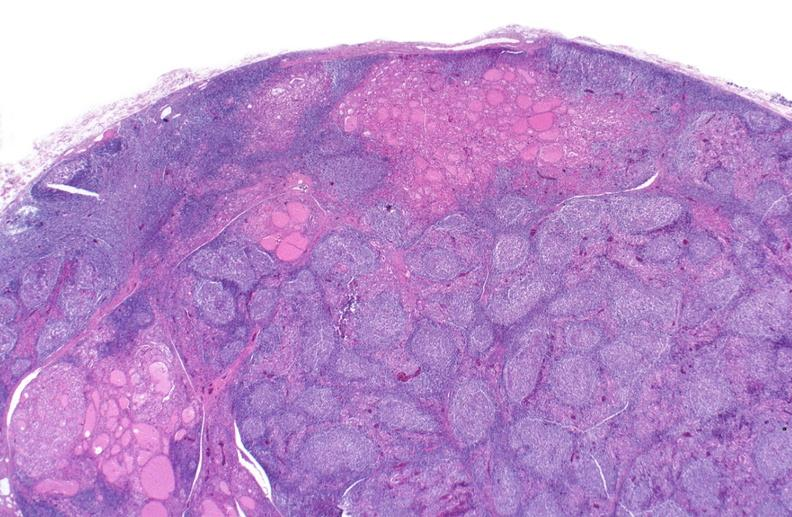s endocrine present?
Answer the question using a single word or phrase. Yes 